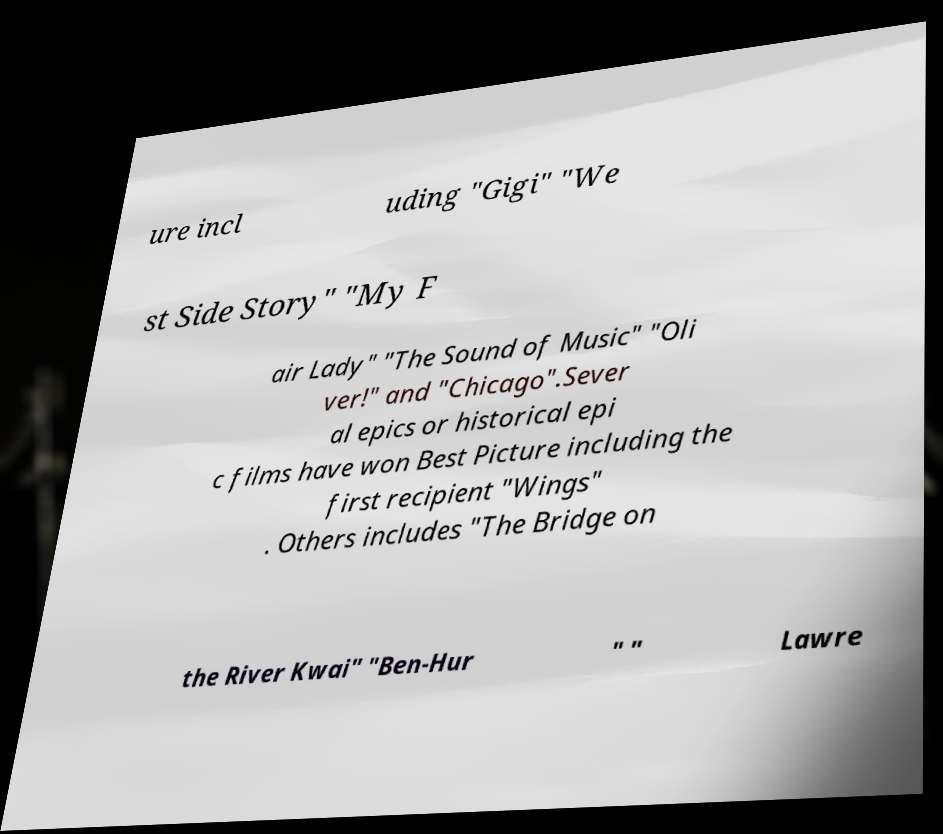Could you extract and type out the text from this image? ure incl uding "Gigi" "We st Side Story" "My F air Lady" "The Sound of Music" "Oli ver!" and "Chicago".Sever al epics or historical epi c films have won Best Picture including the first recipient "Wings" . Others includes "The Bridge on the River Kwai" "Ben-Hur " " Lawre 